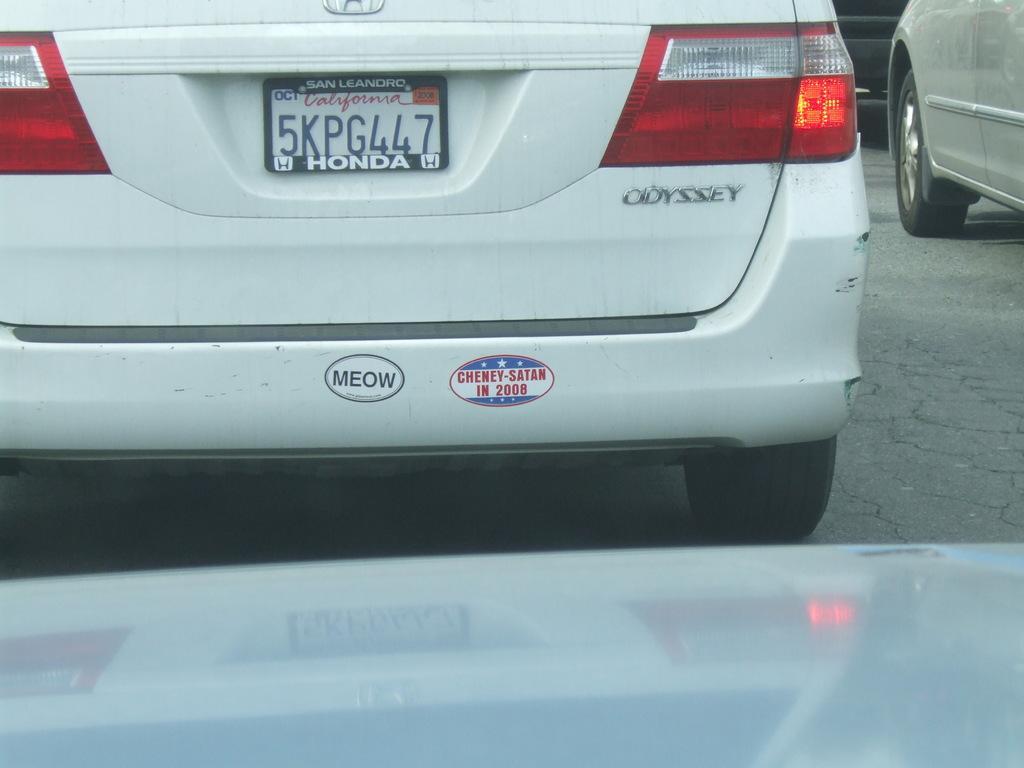Describe this image in one or two sentences. In this image I can see few vehicles on the road. In front I can see the white color car and number plate to the car. 